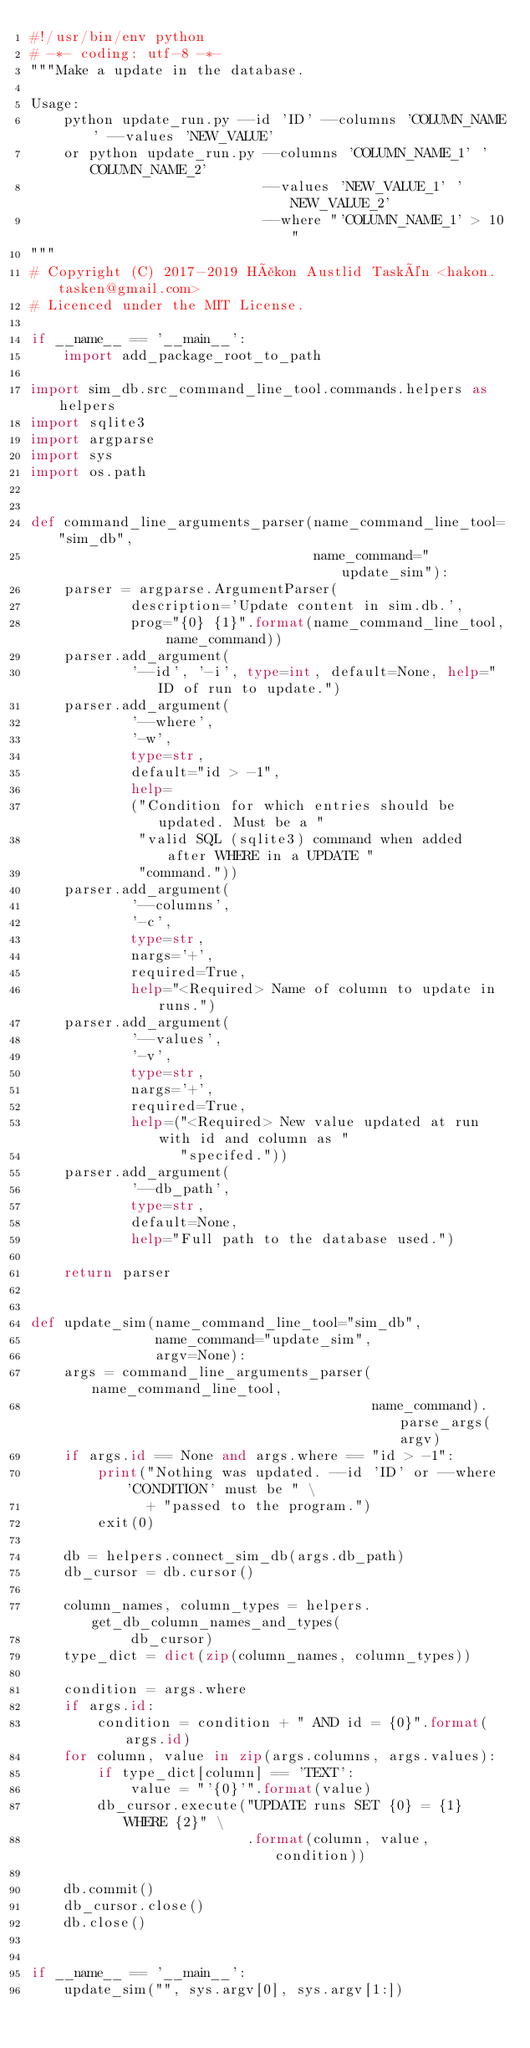<code> <loc_0><loc_0><loc_500><loc_500><_Python_>#!/usr/bin/env python
# -*- coding: utf-8 -*-
"""Make a update in the database.

Usage: 
    python update_run.py --id 'ID' --columns 'COLUMN_NAME' --values 'NEW_VALUE'
    or python update_run.py --columns 'COLUMN_NAME_1' 'COLUMN_NAME_2'
                            --values 'NEW_VALUE_1' 'NEW_VALUE_2'
                            --where "'COLUMN_NAME_1' > 10"
"""
# Copyright (C) 2017-2019 Håkon Austlid Taskén <hakon.tasken@gmail.com>
# Licenced under the MIT License.

if __name__ == '__main__':
    import add_package_root_to_path

import sim_db.src_command_line_tool.commands.helpers as helpers
import sqlite3
import argparse
import sys
import os.path


def command_line_arguments_parser(name_command_line_tool="sim_db",
                                  name_command="update_sim"):
    parser = argparse.ArgumentParser(
            description='Update content in sim.db.',
            prog="{0} {1}".format(name_command_line_tool, name_command))
    parser.add_argument(
            '--id', '-i', type=int, default=None, help="ID of run to update.")
    parser.add_argument(
            '--where',
            '-w',
            type=str,
            default="id > -1",
            help=
            ("Condition for which entries should be updated. Must be a "
             "valid SQL (sqlite3) command when added after WHERE in a UPDATE "
             "command."))
    parser.add_argument(
            '--columns',
            '-c',
            type=str,
            nargs='+',
            required=True,
            help="<Required> Name of column to update in runs.")
    parser.add_argument(
            '--values',
            '-v',
            type=str,
            nargs='+',
            required=True,
            help=("<Required> New value updated at run with id and column as "
                  "specifed."))
    parser.add_argument(
            '--db_path',
            type=str,
            default=None,
            help="Full path to the database used.")

    return parser


def update_sim(name_command_line_tool="sim_db",
               name_command="update_sim",
               argv=None):
    args = command_line_arguments_parser(name_command_line_tool,
                                         name_command).parse_args(argv)
    if args.id == None and args.where == "id > -1":
        print("Nothing was updated. --id 'ID' or --where 'CONDITION' must be " \
              + "passed to the program.")
        exit(0)

    db = helpers.connect_sim_db(args.db_path)
    db_cursor = db.cursor()

    column_names, column_types = helpers.get_db_column_names_and_types(
            db_cursor)
    type_dict = dict(zip(column_names, column_types))

    condition = args.where
    if args.id:
        condition = condition + " AND id = {0}".format(args.id)
    for column, value in zip(args.columns, args.values):
        if type_dict[column] == 'TEXT':
            value = "'{0}'".format(value)
        db_cursor.execute("UPDATE runs SET {0} = {1} WHERE {2}" \
                          .format(column, value, condition))

    db.commit()
    db_cursor.close()
    db.close()


if __name__ == '__main__':
    update_sim("", sys.argv[0], sys.argv[1:])
</code> 